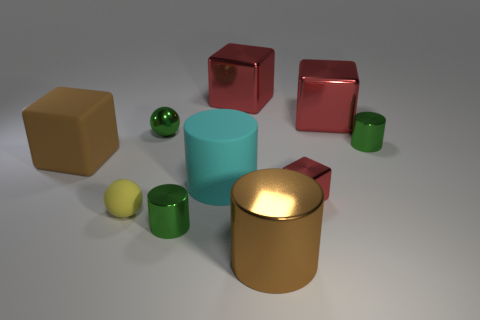Subtract all cyan cylinders. How many red blocks are left? 3 Subtract all gray blocks. Subtract all gray cylinders. How many blocks are left? 4 Subtract all spheres. How many objects are left? 8 Subtract all small cylinders. Subtract all rubber spheres. How many objects are left? 7 Add 1 cyan rubber cylinders. How many cyan rubber cylinders are left? 2 Add 7 big cylinders. How many big cylinders exist? 9 Subtract 0 brown balls. How many objects are left? 10 